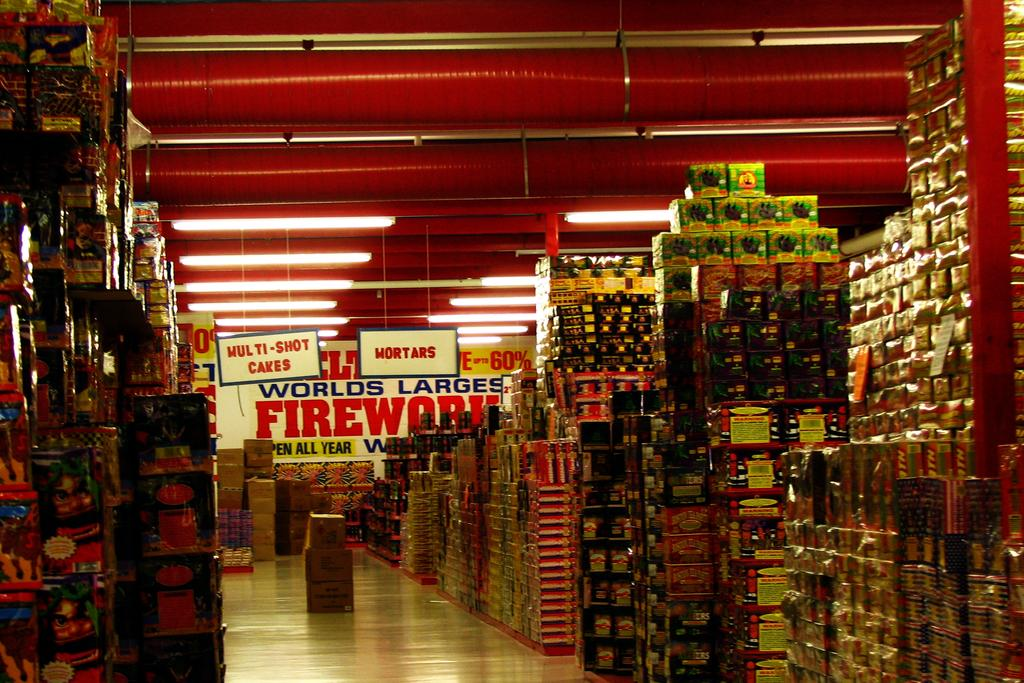<image>
Give a short and clear explanation of the subsequent image. an empty wherhouse store selling the worlds largest fireworks 